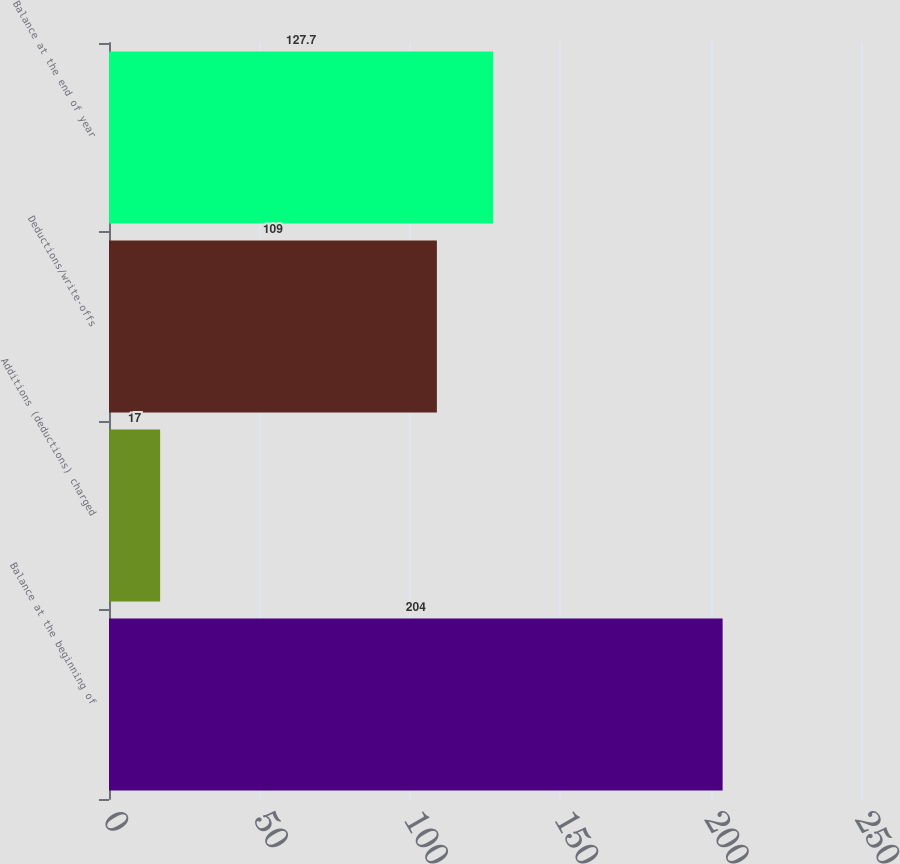Convert chart. <chart><loc_0><loc_0><loc_500><loc_500><bar_chart><fcel>Balance at the beginning of<fcel>Additions (deductions) charged<fcel>Deductions/write-offs<fcel>Balance at the end of year<nl><fcel>204<fcel>17<fcel>109<fcel>127.7<nl></chart> 